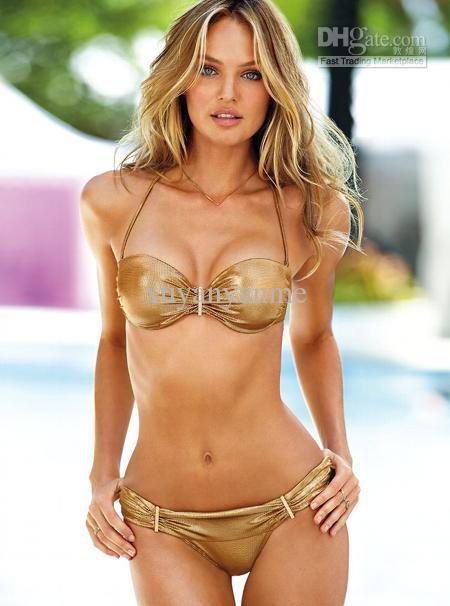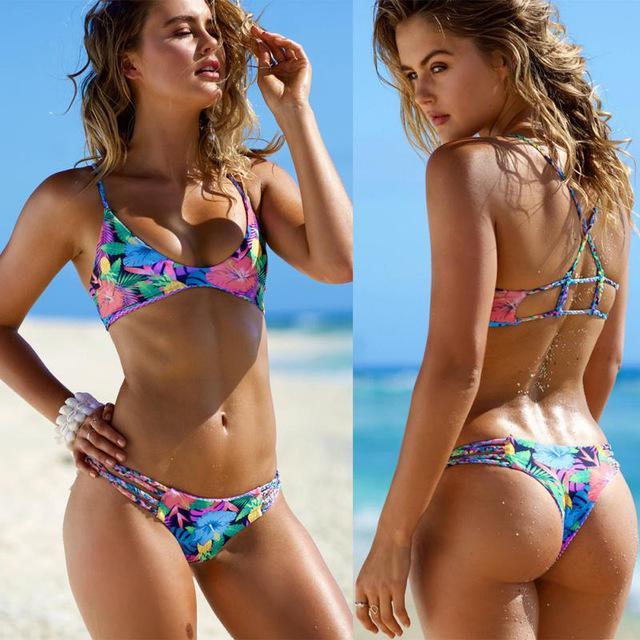The first image is the image on the left, the second image is the image on the right. Given the left and right images, does the statement "The left and right image contains the same number of women in bikinis with at least one in all white." hold true? Answer yes or no. No. 